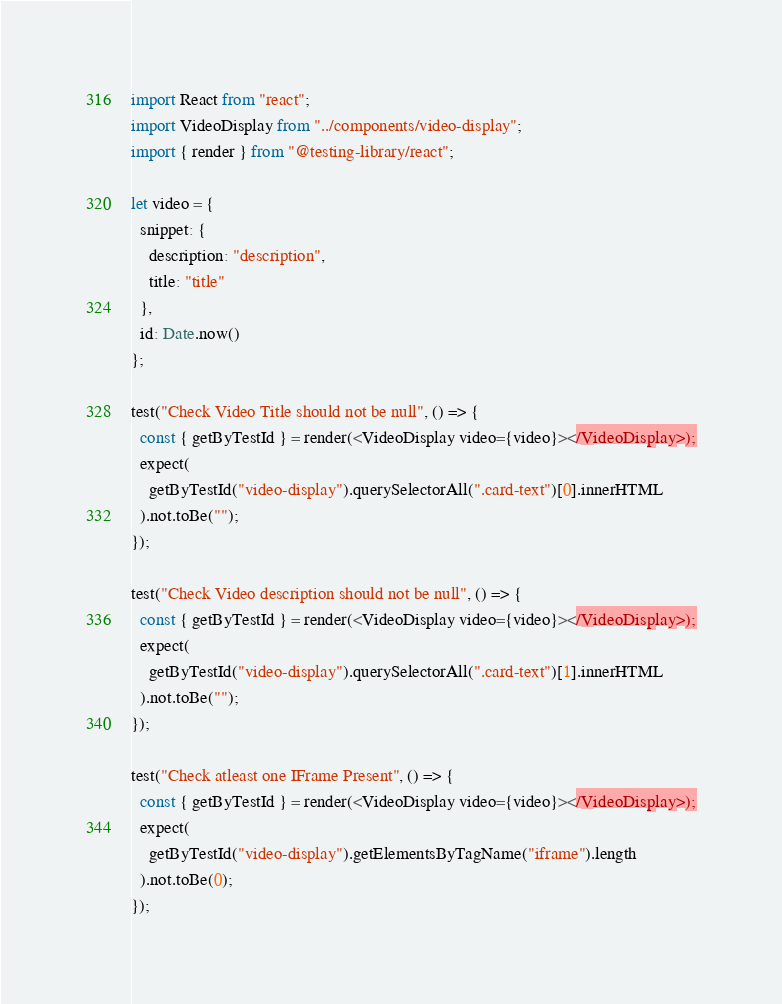Convert code to text. <code><loc_0><loc_0><loc_500><loc_500><_JavaScript_>import React from "react";
import VideoDisplay from "../components/video-display";
import { render } from "@testing-library/react";

let video = {
  snippet: {
    description: "description",
    title: "title"
  },
  id: Date.now()
};

test("Check Video Title should not be null", () => {
  const { getByTestId } = render(<VideoDisplay video={video}></VideoDisplay>);
  expect(
    getByTestId("video-display").querySelectorAll(".card-text")[0].innerHTML
  ).not.toBe("");
});

test("Check Video description should not be null", () => {
  const { getByTestId } = render(<VideoDisplay video={video}></VideoDisplay>);
  expect(
    getByTestId("video-display").querySelectorAll(".card-text")[1].innerHTML
  ).not.toBe("");
});

test("Check atleast one IFrame Present", () => {
  const { getByTestId } = render(<VideoDisplay video={video}></VideoDisplay>);
  expect(
    getByTestId("video-display").getElementsByTagName("iframe").length
  ).not.toBe(0);
});
</code> 